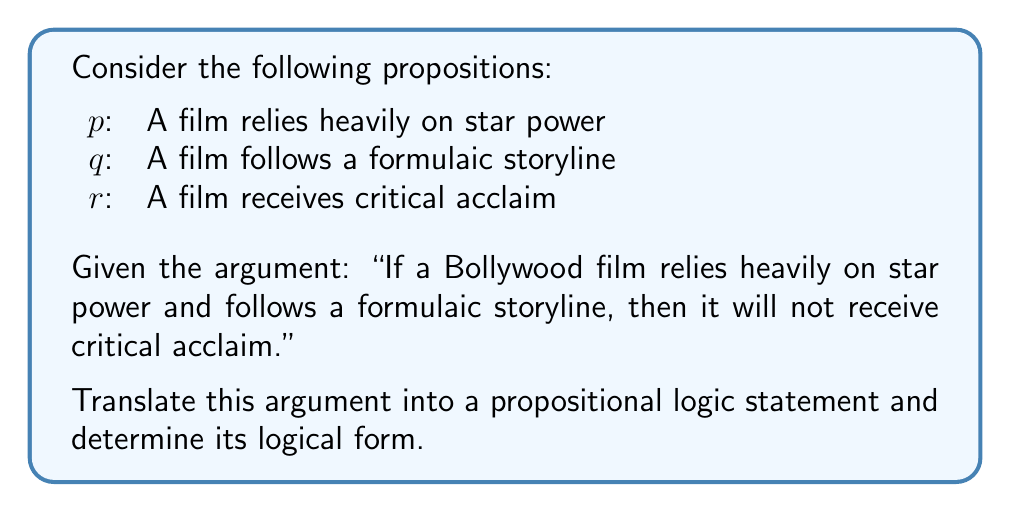Teach me how to tackle this problem. Let's approach this step-by-step:

1) First, we need to translate the given argument into a propositional logic statement:

   "If a Bollywood film relies heavily on star power and follows a formulaic storyline, then it will not receive critical acclaim."

   This can be translated as: If $p$ and $q$, then not $r$.

2) In propositional logic, this statement can be written as:

   $$(p \land q) \rightarrow \neg r$$

3) To determine the logical form, we need to identify the structure of this statement:

   - It's a conditional statement (if-then)
   - The antecedent (if part) is a conjunction ($p \land q$)
   - The consequent (then part) is a negation ($\neg r$)

4) This logical form is known as a "Conjunctive Antecedent Conditional" or "Conjunctive Sufficient Condition."

5) In terms of truth functionality, this statement is false only when $p$ and $q$ are both true, and $r$ is also true. In all other cases, it's true.

6) This logical structure aligns with the film critic's persona, as it formalizes the criticism of Bollywood's reliance on star power and formulaic storytelling, suggesting that these elements are detrimental to critical acclaim.
Answer: $$(p \land q) \rightarrow \neg r$$ 